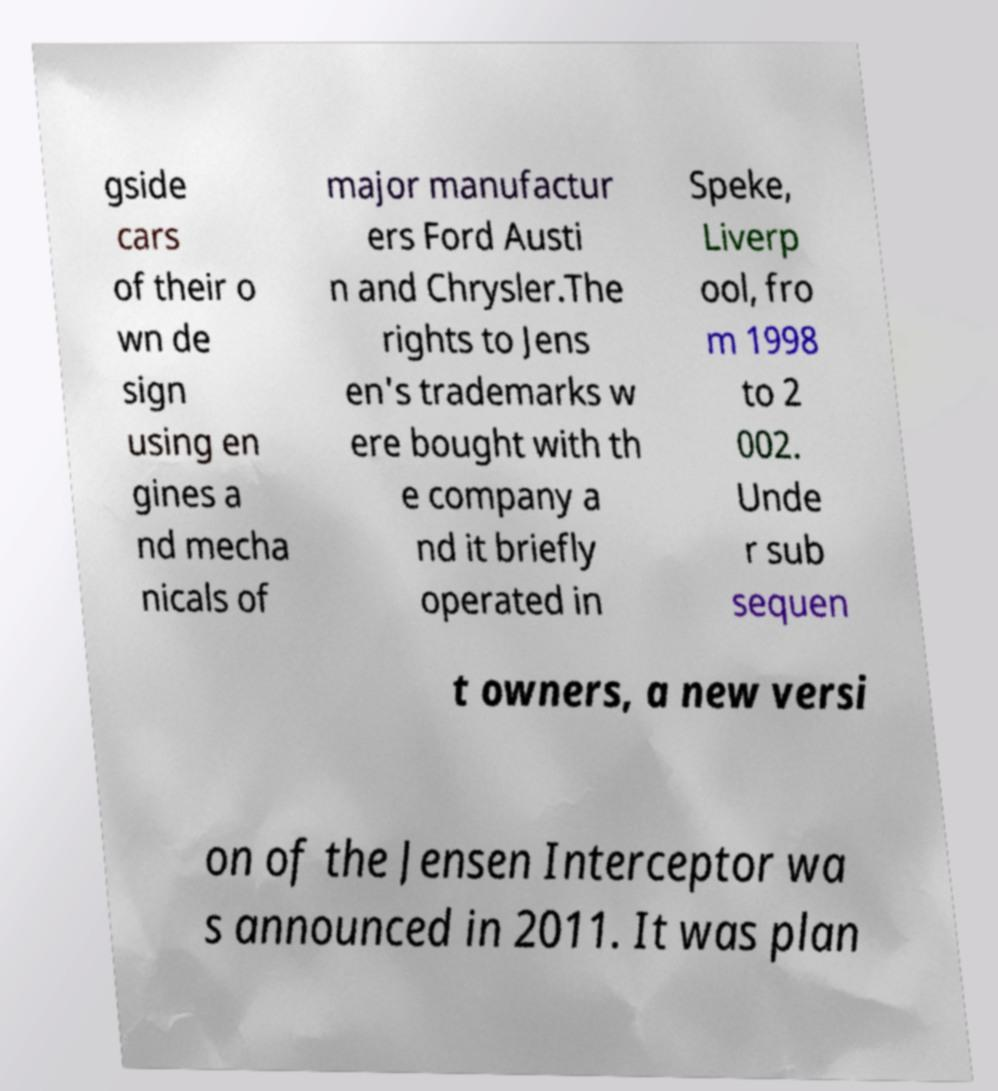Can you accurately transcribe the text from the provided image for me? gside cars of their o wn de sign using en gines a nd mecha nicals of major manufactur ers Ford Austi n and Chrysler.The rights to Jens en's trademarks w ere bought with th e company a nd it briefly operated in Speke, Liverp ool, fro m 1998 to 2 002. Unde r sub sequen t owners, a new versi on of the Jensen Interceptor wa s announced in 2011. It was plan 